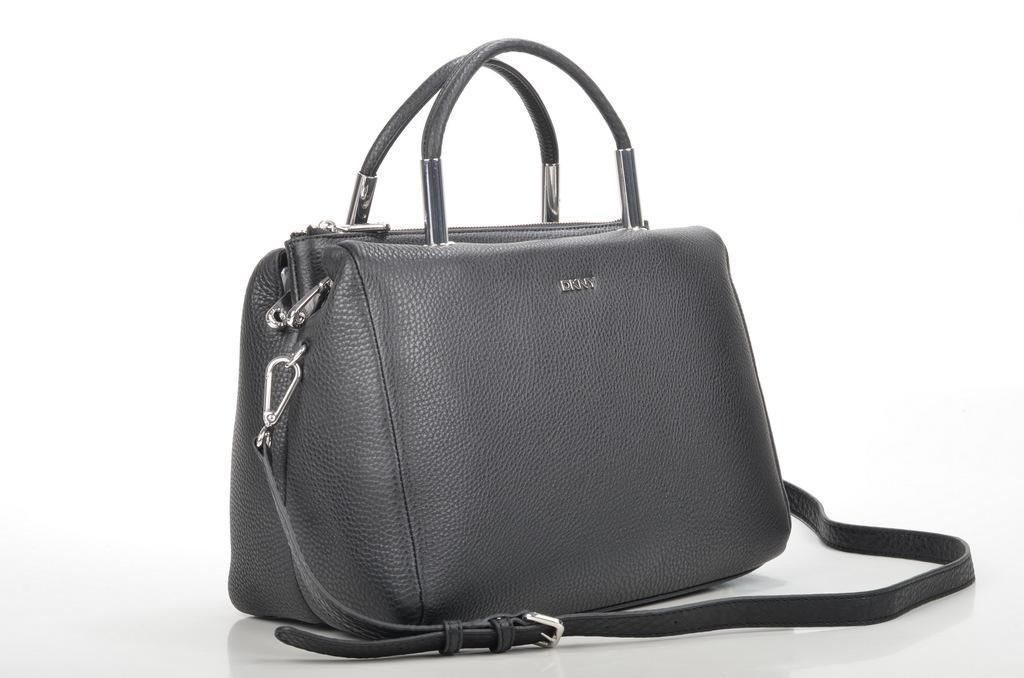In one or two sentences, can you explain what this image depicts? In this image i can see a gray color hand bag and there are the holdings of the hand bag and there is a some text written on the hand bag and on the background i can see a white color. 